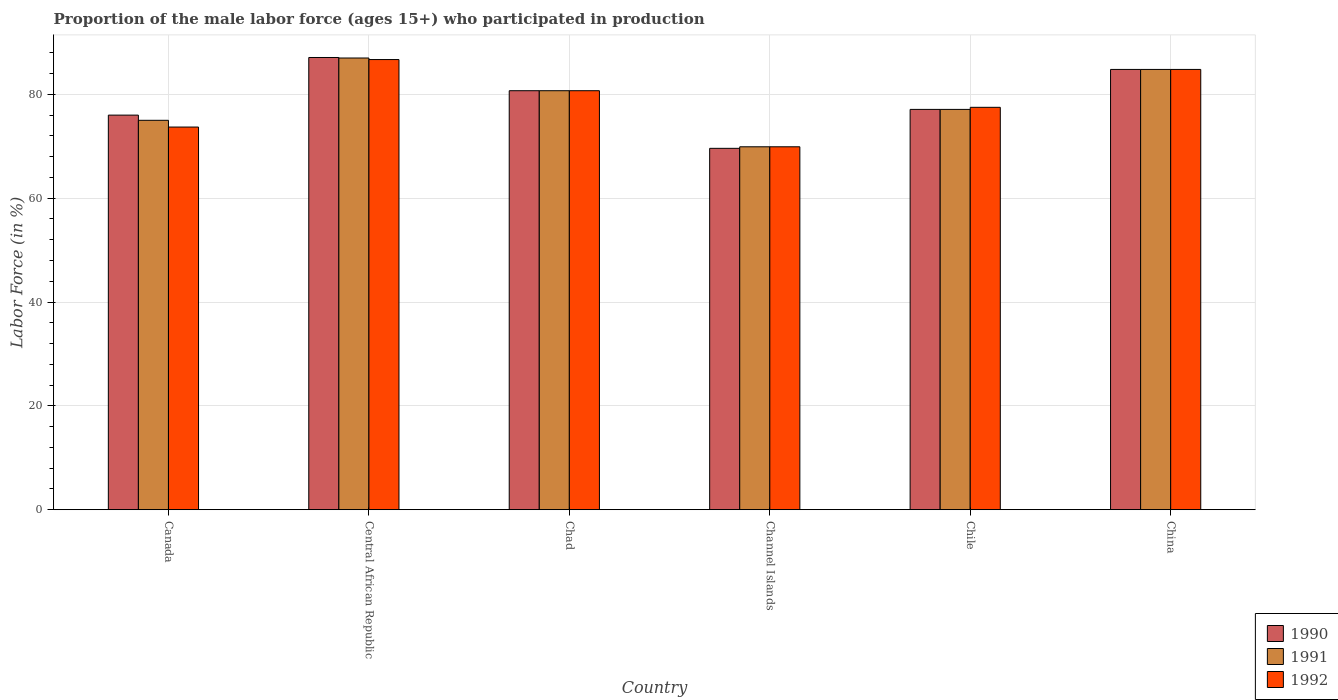How many groups of bars are there?
Provide a short and direct response. 6. How many bars are there on the 2nd tick from the right?
Give a very brief answer. 3. What is the label of the 4th group of bars from the left?
Make the answer very short. Channel Islands. What is the proportion of the male labor force who participated in production in 1991 in Channel Islands?
Keep it short and to the point. 69.9. Across all countries, what is the maximum proportion of the male labor force who participated in production in 1992?
Give a very brief answer. 86.7. Across all countries, what is the minimum proportion of the male labor force who participated in production in 1991?
Offer a terse response. 69.9. In which country was the proportion of the male labor force who participated in production in 1992 maximum?
Offer a very short reply. Central African Republic. In which country was the proportion of the male labor force who participated in production in 1992 minimum?
Offer a very short reply. Channel Islands. What is the total proportion of the male labor force who participated in production in 1991 in the graph?
Your answer should be very brief. 474.5. What is the difference between the proportion of the male labor force who participated in production in 1991 in Channel Islands and that in Chile?
Provide a succinct answer. -7.2. What is the difference between the proportion of the male labor force who participated in production in 1991 in Chile and the proportion of the male labor force who participated in production in 1992 in Canada?
Your answer should be very brief. 3.4. What is the average proportion of the male labor force who participated in production in 1991 per country?
Give a very brief answer. 79.08. In how many countries, is the proportion of the male labor force who participated in production in 1990 greater than 52 %?
Give a very brief answer. 6. What is the ratio of the proportion of the male labor force who participated in production in 1991 in Central African Republic to that in Chile?
Keep it short and to the point. 1.13. Is the difference between the proportion of the male labor force who participated in production in 1991 in Central African Republic and Channel Islands greater than the difference between the proportion of the male labor force who participated in production in 1990 in Central African Republic and Channel Islands?
Offer a very short reply. No. What is the difference between the highest and the second highest proportion of the male labor force who participated in production in 1990?
Ensure brevity in your answer.  -4.1. In how many countries, is the proportion of the male labor force who participated in production in 1990 greater than the average proportion of the male labor force who participated in production in 1990 taken over all countries?
Provide a short and direct response. 3. What does the 2nd bar from the left in Chad represents?
Make the answer very short. 1991. How many bars are there?
Your response must be concise. 18. What is the difference between two consecutive major ticks on the Y-axis?
Your response must be concise. 20. Where does the legend appear in the graph?
Offer a terse response. Bottom right. What is the title of the graph?
Your answer should be compact. Proportion of the male labor force (ages 15+) who participated in production. Does "1987" appear as one of the legend labels in the graph?
Ensure brevity in your answer.  No. What is the Labor Force (in %) in 1992 in Canada?
Your answer should be compact. 73.7. What is the Labor Force (in %) of 1990 in Central African Republic?
Keep it short and to the point. 87.1. What is the Labor Force (in %) in 1991 in Central African Republic?
Your answer should be very brief. 87. What is the Labor Force (in %) in 1992 in Central African Republic?
Your answer should be compact. 86.7. What is the Labor Force (in %) in 1990 in Chad?
Make the answer very short. 80.7. What is the Labor Force (in %) of 1991 in Chad?
Your answer should be very brief. 80.7. What is the Labor Force (in %) of 1992 in Chad?
Offer a terse response. 80.7. What is the Labor Force (in %) in 1990 in Channel Islands?
Make the answer very short. 69.6. What is the Labor Force (in %) in 1991 in Channel Islands?
Provide a succinct answer. 69.9. What is the Labor Force (in %) of 1992 in Channel Islands?
Your response must be concise. 69.9. What is the Labor Force (in %) of 1990 in Chile?
Your answer should be very brief. 77.1. What is the Labor Force (in %) of 1991 in Chile?
Keep it short and to the point. 77.1. What is the Labor Force (in %) in 1992 in Chile?
Give a very brief answer. 77.5. What is the Labor Force (in %) in 1990 in China?
Offer a very short reply. 84.8. What is the Labor Force (in %) of 1991 in China?
Provide a short and direct response. 84.8. What is the Labor Force (in %) in 1992 in China?
Give a very brief answer. 84.8. Across all countries, what is the maximum Labor Force (in %) in 1990?
Your answer should be very brief. 87.1. Across all countries, what is the maximum Labor Force (in %) in 1992?
Your answer should be very brief. 86.7. Across all countries, what is the minimum Labor Force (in %) of 1990?
Your response must be concise. 69.6. Across all countries, what is the minimum Labor Force (in %) of 1991?
Give a very brief answer. 69.9. Across all countries, what is the minimum Labor Force (in %) in 1992?
Your answer should be very brief. 69.9. What is the total Labor Force (in %) in 1990 in the graph?
Provide a short and direct response. 475.3. What is the total Labor Force (in %) in 1991 in the graph?
Your answer should be compact. 474.5. What is the total Labor Force (in %) of 1992 in the graph?
Ensure brevity in your answer.  473.3. What is the difference between the Labor Force (in %) of 1991 in Canada and that in Chad?
Provide a succinct answer. -5.7. What is the difference between the Labor Force (in %) in 1992 in Canada and that in Chad?
Give a very brief answer. -7. What is the difference between the Labor Force (in %) of 1990 in Canada and that in Channel Islands?
Ensure brevity in your answer.  6.4. What is the difference between the Labor Force (in %) in 1991 in Canada and that in Channel Islands?
Give a very brief answer. 5.1. What is the difference between the Labor Force (in %) in 1990 in Canada and that in Chile?
Keep it short and to the point. -1.1. What is the difference between the Labor Force (in %) in 1991 in Canada and that in Chile?
Provide a short and direct response. -2.1. What is the difference between the Labor Force (in %) of 1992 in Canada and that in Chile?
Keep it short and to the point. -3.8. What is the difference between the Labor Force (in %) in 1990 in Canada and that in China?
Make the answer very short. -8.8. What is the difference between the Labor Force (in %) in 1992 in Canada and that in China?
Keep it short and to the point. -11.1. What is the difference between the Labor Force (in %) of 1991 in Central African Republic and that in Chad?
Your answer should be very brief. 6.3. What is the difference between the Labor Force (in %) of 1992 in Central African Republic and that in Chad?
Your answer should be very brief. 6. What is the difference between the Labor Force (in %) in 1990 in Central African Republic and that in Channel Islands?
Your answer should be very brief. 17.5. What is the difference between the Labor Force (in %) in 1992 in Central African Republic and that in Channel Islands?
Keep it short and to the point. 16.8. What is the difference between the Labor Force (in %) in 1991 in Central African Republic and that in Chile?
Offer a terse response. 9.9. What is the difference between the Labor Force (in %) of 1992 in Central African Republic and that in Chile?
Offer a very short reply. 9.2. What is the difference between the Labor Force (in %) of 1991 in Central African Republic and that in China?
Your response must be concise. 2.2. What is the difference between the Labor Force (in %) in 1991 in Chad and that in Channel Islands?
Ensure brevity in your answer.  10.8. What is the difference between the Labor Force (in %) in 1992 in Chad and that in Channel Islands?
Your answer should be very brief. 10.8. What is the difference between the Labor Force (in %) of 1992 in Chad and that in Chile?
Keep it short and to the point. 3.2. What is the difference between the Labor Force (in %) of 1990 in Chad and that in China?
Keep it short and to the point. -4.1. What is the difference between the Labor Force (in %) in 1990 in Channel Islands and that in Chile?
Offer a terse response. -7.5. What is the difference between the Labor Force (in %) of 1990 in Channel Islands and that in China?
Offer a very short reply. -15.2. What is the difference between the Labor Force (in %) in 1991 in Channel Islands and that in China?
Your response must be concise. -14.9. What is the difference between the Labor Force (in %) in 1992 in Channel Islands and that in China?
Your answer should be compact. -14.9. What is the difference between the Labor Force (in %) in 1990 in Canada and the Labor Force (in %) in 1991 in Central African Republic?
Offer a very short reply. -11. What is the difference between the Labor Force (in %) in 1990 in Canada and the Labor Force (in %) in 1992 in Central African Republic?
Offer a very short reply. -10.7. What is the difference between the Labor Force (in %) of 1991 in Canada and the Labor Force (in %) of 1992 in Central African Republic?
Offer a terse response. -11.7. What is the difference between the Labor Force (in %) of 1990 in Canada and the Labor Force (in %) of 1991 in Chad?
Your answer should be very brief. -4.7. What is the difference between the Labor Force (in %) in 1990 in Canada and the Labor Force (in %) in 1992 in Chad?
Provide a succinct answer. -4.7. What is the difference between the Labor Force (in %) in 1991 in Canada and the Labor Force (in %) in 1992 in Chad?
Provide a short and direct response. -5.7. What is the difference between the Labor Force (in %) of 1990 in Canada and the Labor Force (in %) of 1992 in Channel Islands?
Your answer should be very brief. 6.1. What is the difference between the Labor Force (in %) in 1991 in Canada and the Labor Force (in %) in 1992 in Channel Islands?
Your response must be concise. 5.1. What is the difference between the Labor Force (in %) in 1990 in Canada and the Labor Force (in %) in 1991 in Chile?
Your response must be concise. -1.1. What is the difference between the Labor Force (in %) of 1991 in Canada and the Labor Force (in %) of 1992 in Chile?
Your answer should be very brief. -2.5. What is the difference between the Labor Force (in %) of 1991 in Canada and the Labor Force (in %) of 1992 in China?
Your answer should be very brief. -9.8. What is the difference between the Labor Force (in %) in 1990 in Central African Republic and the Labor Force (in %) in 1992 in Chad?
Your response must be concise. 6.4. What is the difference between the Labor Force (in %) in 1991 in Central African Republic and the Labor Force (in %) in 1992 in Chad?
Keep it short and to the point. 6.3. What is the difference between the Labor Force (in %) of 1990 in Central African Republic and the Labor Force (in %) of 1991 in Channel Islands?
Provide a short and direct response. 17.2. What is the difference between the Labor Force (in %) in 1990 in Central African Republic and the Labor Force (in %) in 1992 in Chile?
Offer a terse response. 9.6. What is the difference between the Labor Force (in %) of 1991 in Central African Republic and the Labor Force (in %) of 1992 in Chile?
Make the answer very short. 9.5. What is the difference between the Labor Force (in %) in 1990 in Central African Republic and the Labor Force (in %) in 1991 in China?
Keep it short and to the point. 2.3. What is the difference between the Labor Force (in %) of 1991 in Chad and the Labor Force (in %) of 1992 in Channel Islands?
Provide a succinct answer. 10.8. What is the difference between the Labor Force (in %) in 1990 in Chad and the Labor Force (in %) in 1991 in Chile?
Keep it short and to the point. 3.6. What is the difference between the Labor Force (in %) in 1990 in Chad and the Labor Force (in %) in 1992 in Chile?
Offer a terse response. 3.2. What is the difference between the Labor Force (in %) in 1990 in Chad and the Labor Force (in %) in 1991 in China?
Keep it short and to the point. -4.1. What is the difference between the Labor Force (in %) in 1991 in Chad and the Labor Force (in %) in 1992 in China?
Make the answer very short. -4.1. What is the difference between the Labor Force (in %) in 1991 in Channel Islands and the Labor Force (in %) in 1992 in Chile?
Provide a short and direct response. -7.6. What is the difference between the Labor Force (in %) in 1990 in Channel Islands and the Labor Force (in %) in 1991 in China?
Give a very brief answer. -15.2. What is the difference between the Labor Force (in %) in 1990 in Channel Islands and the Labor Force (in %) in 1992 in China?
Your answer should be compact. -15.2. What is the difference between the Labor Force (in %) in 1991 in Channel Islands and the Labor Force (in %) in 1992 in China?
Offer a terse response. -14.9. What is the difference between the Labor Force (in %) in 1990 in Chile and the Labor Force (in %) in 1991 in China?
Keep it short and to the point. -7.7. What is the average Labor Force (in %) of 1990 per country?
Your answer should be compact. 79.22. What is the average Labor Force (in %) in 1991 per country?
Provide a succinct answer. 79.08. What is the average Labor Force (in %) in 1992 per country?
Make the answer very short. 78.88. What is the difference between the Labor Force (in %) of 1990 and Labor Force (in %) of 1991 in Canada?
Make the answer very short. 1. What is the difference between the Labor Force (in %) in 1991 and Labor Force (in %) in 1992 in Central African Republic?
Ensure brevity in your answer.  0.3. What is the difference between the Labor Force (in %) in 1991 and Labor Force (in %) in 1992 in Chad?
Your response must be concise. 0. What is the difference between the Labor Force (in %) in 1990 and Labor Force (in %) in 1992 in Channel Islands?
Offer a very short reply. -0.3. What is the difference between the Labor Force (in %) in 1990 and Labor Force (in %) in 1991 in Chile?
Make the answer very short. 0. What is the difference between the Labor Force (in %) of 1990 and Labor Force (in %) of 1992 in Chile?
Offer a very short reply. -0.4. What is the difference between the Labor Force (in %) of 1990 and Labor Force (in %) of 1992 in China?
Provide a short and direct response. 0. What is the difference between the Labor Force (in %) in 1991 and Labor Force (in %) in 1992 in China?
Make the answer very short. 0. What is the ratio of the Labor Force (in %) in 1990 in Canada to that in Central African Republic?
Your answer should be very brief. 0.87. What is the ratio of the Labor Force (in %) of 1991 in Canada to that in Central African Republic?
Make the answer very short. 0.86. What is the ratio of the Labor Force (in %) in 1992 in Canada to that in Central African Republic?
Make the answer very short. 0.85. What is the ratio of the Labor Force (in %) of 1990 in Canada to that in Chad?
Offer a very short reply. 0.94. What is the ratio of the Labor Force (in %) of 1991 in Canada to that in Chad?
Offer a very short reply. 0.93. What is the ratio of the Labor Force (in %) in 1992 in Canada to that in Chad?
Provide a succinct answer. 0.91. What is the ratio of the Labor Force (in %) of 1990 in Canada to that in Channel Islands?
Your response must be concise. 1.09. What is the ratio of the Labor Force (in %) in 1991 in Canada to that in Channel Islands?
Your answer should be compact. 1.07. What is the ratio of the Labor Force (in %) of 1992 in Canada to that in Channel Islands?
Provide a short and direct response. 1.05. What is the ratio of the Labor Force (in %) of 1990 in Canada to that in Chile?
Your answer should be compact. 0.99. What is the ratio of the Labor Force (in %) of 1991 in Canada to that in Chile?
Offer a very short reply. 0.97. What is the ratio of the Labor Force (in %) of 1992 in Canada to that in Chile?
Offer a very short reply. 0.95. What is the ratio of the Labor Force (in %) in 1990 in Canada to that in China?
Ensure brevity in your answer.  0.9. What is the ratio of the Labor Force (in %) of 1991 in Canada to that in China?
Offer a very short reply. 0.88. What is the ratio of the Labor Force (in %) of 1992 in Canada to that in China?
Make the answer very short. 0.87. What is the ratio of the Labor Force (in %) of 1990 in Central African Republic to that in Chad?
Offer a very short reply. 1.08. What is the ratio of the Labor Force (in %) of 1991 in Central African Republic to that in Chad?
Make the answer very short. 1.08. What is the ratio of the Labor Force (in %) in 1992 in Central African Republic to that in Chad?
Ensure brevity in your answer.  1.07. What is the ratio of the Labor Force (in %) of 1990 in Central African Republic to that in Channel Islands?
Offer a terse response. 1.25. What is the ratio of the Labor Force (in %) of 1991 in Central African Republic to that in Channel Islands?
Your response must be concise. 1.24. What is the ratio of the Labor Force (in %) of 1992 in Central African Republic to that in Channel Islands?
Give a very brief answer. 1.24. What is the ratio of the Labor Force (in %) in 1990 in Central African Republic to that in Chile?
Provide a succinct answer. 1.13. What is the ratio of the Labor Force (in %) in 1991 in Central African Republic to that in Chile?
Provide a short and direct response. 1.13. What is the ratio of the Labor Force (in %) in 1992 in Central African Republic to that in Chile?
Your answer should be very brief. 1.12. What is the ratio of the Labor Force (in %) of 1990 in Central African Republic to that in China?
Give a very brief answer. 1.03. What is the ratio of the Labor Force (in %) of 1991 in Central African Republic to that in China?
Offer a very short reply. 1.03. What is the ratio of the Labor Force (in %) in 1992 in Central African Republic to that in China?
Give a very brief answer. 1.02. What is the ratio of the Labor Force (in %) of 1990 in Chad to that in Channel Islands?
Make the answer very short. 1.16. What is the ratio of the Labor Force (in %) in 1991 in Chad to that in Channel Islands?
Provide a short and direct response. 1.15. What is the ratio of the Labor Force (in %) of 1992 in Chad to that in Channel Islands?
Your response must be concise. 1.15. What is the ratio of the Labor Force (in %) of 1990 in Chad to that in Chile?
Your answer should be very brief. 1.05. What is the ratio of the Labor Force (in %) of 1991 in Chad to that in Chile?
Give a very brief answer. 1.05. What is the ratio of the Labor Force (in %) in 1992 in Chad to that in Chile?
Offer a very short reply. 1.04. What is the ratio of the Labor Force (in %) in 1990 in Chad to that in China?
Keep it short and to the point. 0.95. What is the ratio of the Labor Force (in %) in 1991 in Chad to that in China?
Offer a terse response. 0.95. What is the ratio of the Labor Force (in %) in 1992 in Chad to that in China?
Your answer should be compact. 0.95. What is the ratio of the Labor Force (in %) in 1990 in Channel Islands to that in Chile?
Keep it short and to the point. 0.9. What is the ratio of the Labor Force (in %) of 1991 in Channel Islands to that in Chile?
Keep it short and to the point. 0.91. What is the ratio of the Labor Force (in %) of 1992 in Channel Islands to that in Chile?
Your answer should be compact. 0.9. What is the ratio of the Labor Force (in %) of 1990 in Channel Islands to that in China?
Offer a terse response. 0.82. What is the ratio of the Labor Force (in %) of 1991 in Channel Islands to that in China?
Provide a short and direct response. 0.82. What is the ratio of the Labor Force (in %) in 1992 in Channel Islands to that in China?
Your answer should be compact. 0.82. What is the ratio of the Labor Force (in %) of 1990 in Chile to that in China?
Your answer should be compact. 0.91. What is the ratio of the Labor Force (in %) in 1991 in Chile to that in China?
Your answer should be very brief. 0.91. What is the ratio of the Labor Force (in %) in 1992 in Chile to that in China?
Your response must be concise. 0.91. What is the difference between the highest and the second highest Labor Force (in %) of 1991?
Your answer should be very brief. 2.2. What is the difference between the highest and the second highest Labor Force (in %) of 1992?
Offer a terse response. 1.9. What is the difference between the highest and the lowest Labor Force (in %) in 1990?
Your response must be concise. 17.5. What is the difference between the highest and the lowest Labor Force (in %) in 1991?
Make the answer very short. 17.1. 